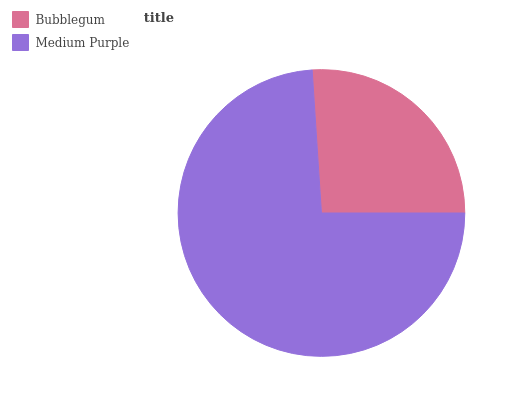Is Bubblegum the minimum?
Answer yes or no. Yes. Is Medium Purple the maximum?
Answer yes or no. Yes. Is Medium Purple the minimum?
Answer yes or no. No. Is Medium Purple greater than Bubblegum?
Answer yes or no. Yes. Is Bubblegum less than Medium Purple?
Answer yes or no. Yes. Is Bubblegum greater than Medium Purple?
Answer yes or no. No. Is Medium Purple less than Bubblegum?
Answer yes or no. No. Is Medium Purple the high median?
Answer yes or no. Yes. Is Bubblegum the low median?
Answer yes or no. Yes. Is Bubblegum the high median?
Answer yes or no. No. Is Medium Purple the low median?
Answer yes or no. No. 